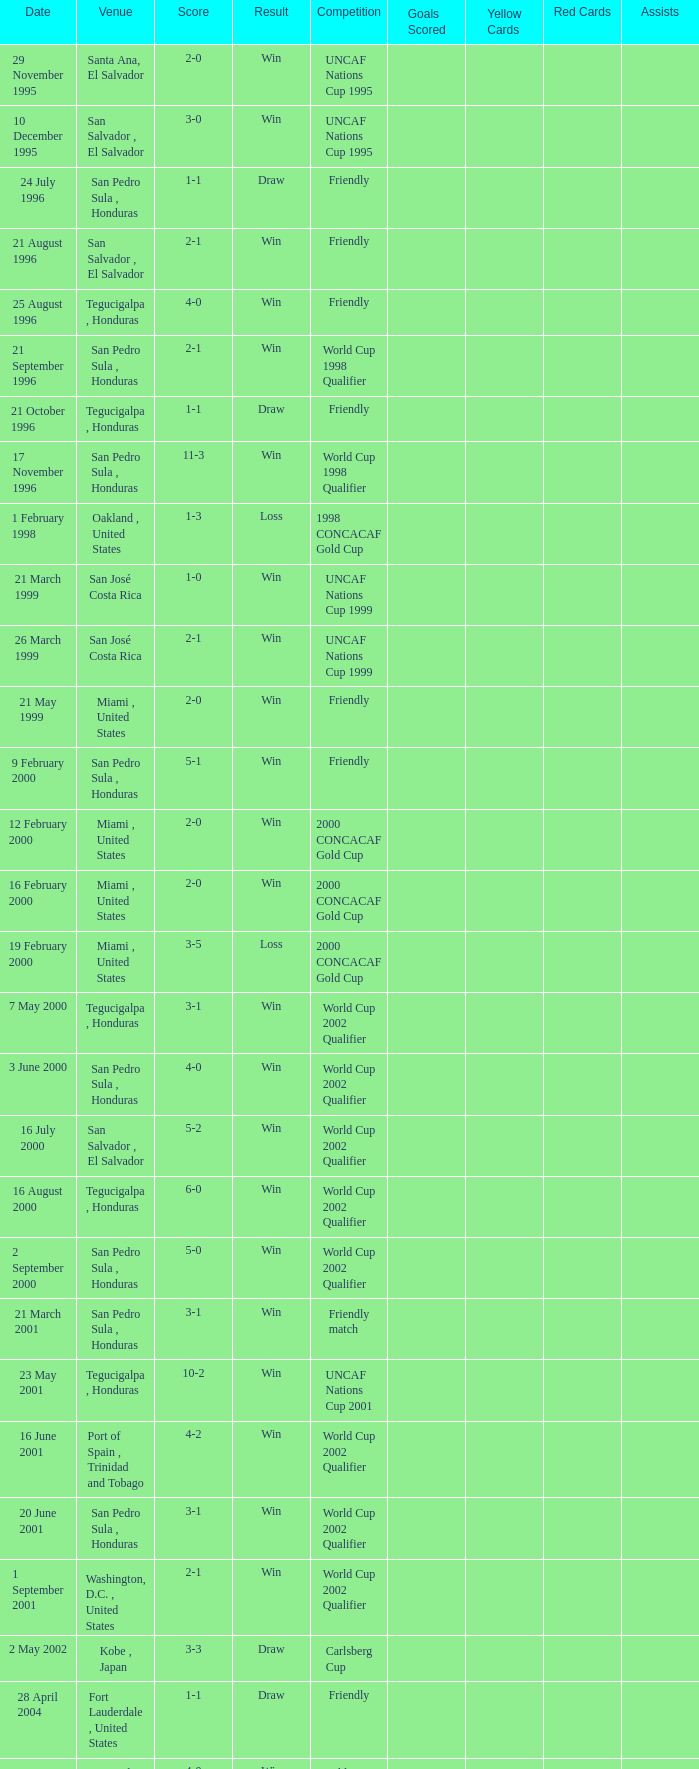State the points tally on 7th may 200 3-1. 